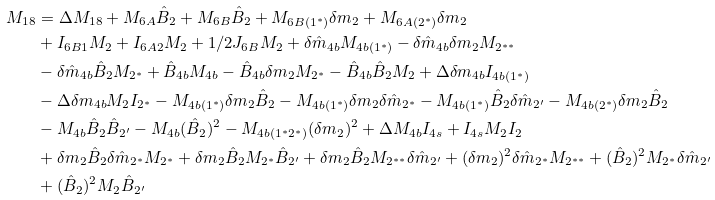Convert formula to latex. <formula><loc_0><loc_0><loc_500><loc_500>M _ { 1 8 } & = \Delta M _ { 1 8 } + M _ { 6 A } \hat { B } _ { 2 } + M _ { 6 B } \hat { B } _ { 2 } + M _ { 6 B ( 1 ^ { \ast } ) } \delta m _ { 2 } + M _ { 6 A ( 2 ^ { \ast } ) } \delta m _ { 2 } \\ & + I _ { 6 B 1 } M _ { 2 } + I _ { 6 A 2 } M _ { 2 } + 1 / 2 J _ { 6 B } M _ { 2 } + \delta \hat { m } _ { 4 b } M _ { 4 b ( 1 ^ { \ast } ) } - \delta \hat { m } _ { 4 b } \delta m _ { 2 } M _ { 2 ^ { \ast \ast } } \\ & - \delta \hat { m } _ { 4 b } \hat { B } _ { 2 } M _ { 2 ^ { \ast } } + \hat { B } _ { 4 b } M _ { 4 b } - \hat { B } _ { 4 b } \delta m _ { 2 } M _ { 2 ^ { \ast } } - \hat { B } _ { 4 b } \hat { B } _ { 2 } M _ { 2 } + \Delta \delta m _ { 4 b } I _ { 4 b ( 1 ^ { \ast } ) } \\ & - \Delta \delta m _ { 4 b } M _ { 2 } I _ { 2 ^ { \ast } } - M _ { 4 b ( 1 ^ { \ast } ) } \delta m _ { 2 } \hat { B } _ { 2 } - M _ { 4 b ( 1 ^ { \ast } ) } \delta m _ { 2 } \delta \hat { m } _ { 2 ^ { \ast } } - M _ { 4 b ( 1 ^ { \ast } ) } \hat { B } _ { 2 } \delta \hat { m } _ { 2 ^ { \prime } } - M _ { 4 b ( 2 ^ { \ast } ) } \delta m _ { 2 } \hat { B } _ { 2 } \\ & - M _ { 4 b } \hat { B } _ { 2 } \hat { B } _ { 2 ^ { \prime } } - M _ { 4 b } ( \hat { B } _ { 2 } ) ^ { 2 } - M _ { 4 b ( 1 ^ { \ast } 2 ^ { \ast } ) } ( \delta m _ { 2 } ) ^ { 2 } + \Delta M _ { 4 b } I _ { 4 s } + I _ { 4 s } M _ { 2 } I _ { 2 } \\ & + \delta m _ { 2 } \hat { B } _ { 2 } \delta \hat { m } _ { 2 ^ { \ast } } M _ { 2 ^ { \ast } } + \delta m _ { 2 } \hat { B } _ { 2 } M _ { 2 ^ { \ast } } \hat { B } _ { 2 ^ { \prime } } + \delta m _ { 2 } \hat { B } _ { 2 } M _ { 2 ^ { \ast \ast } } \delta \hat { m } _ { 2 ^ { \prime } } + ( \delta m _ { 2 } ) ^ { 2 } \delta \hat { m } _ { 2 ^ { \ast } } M _ { 2 ^ { \ast \ast } } + ( \hat { B } _ { 2 } ) ^ { 2 } M _ { 2 ^ { \ast } } \delta \hat { m } _ { 2 ^ { \prime } } \\ & + ( \hat { B } _ { 2 } ) ^ { 2 } M _ { 2 } \hat { B } _ { 2 ^ { \prime } }</formula> 